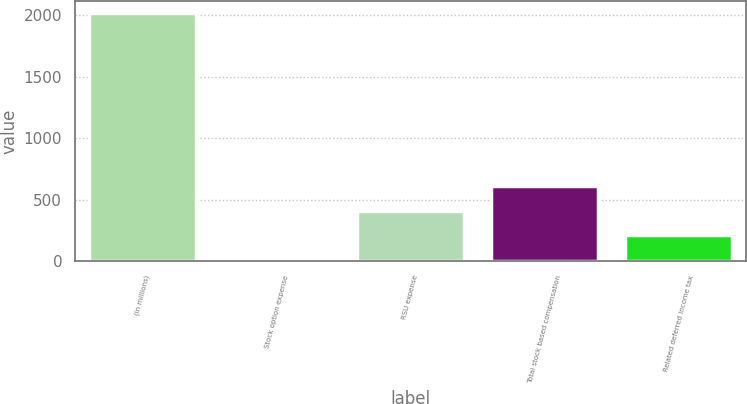<chart> <loc_0><loc_0><loc_500><loc_500><bar_chart><fcel>(in millions)<fcel>Stock option expense<fcel>RSU expense<fcel>Total stock based compensation<fcel>Related deferred income tax<nl><fcel>2016<fcel>10.6<fcel>411.68<fcel>612.22<fcel>211.14<nl></chart> 